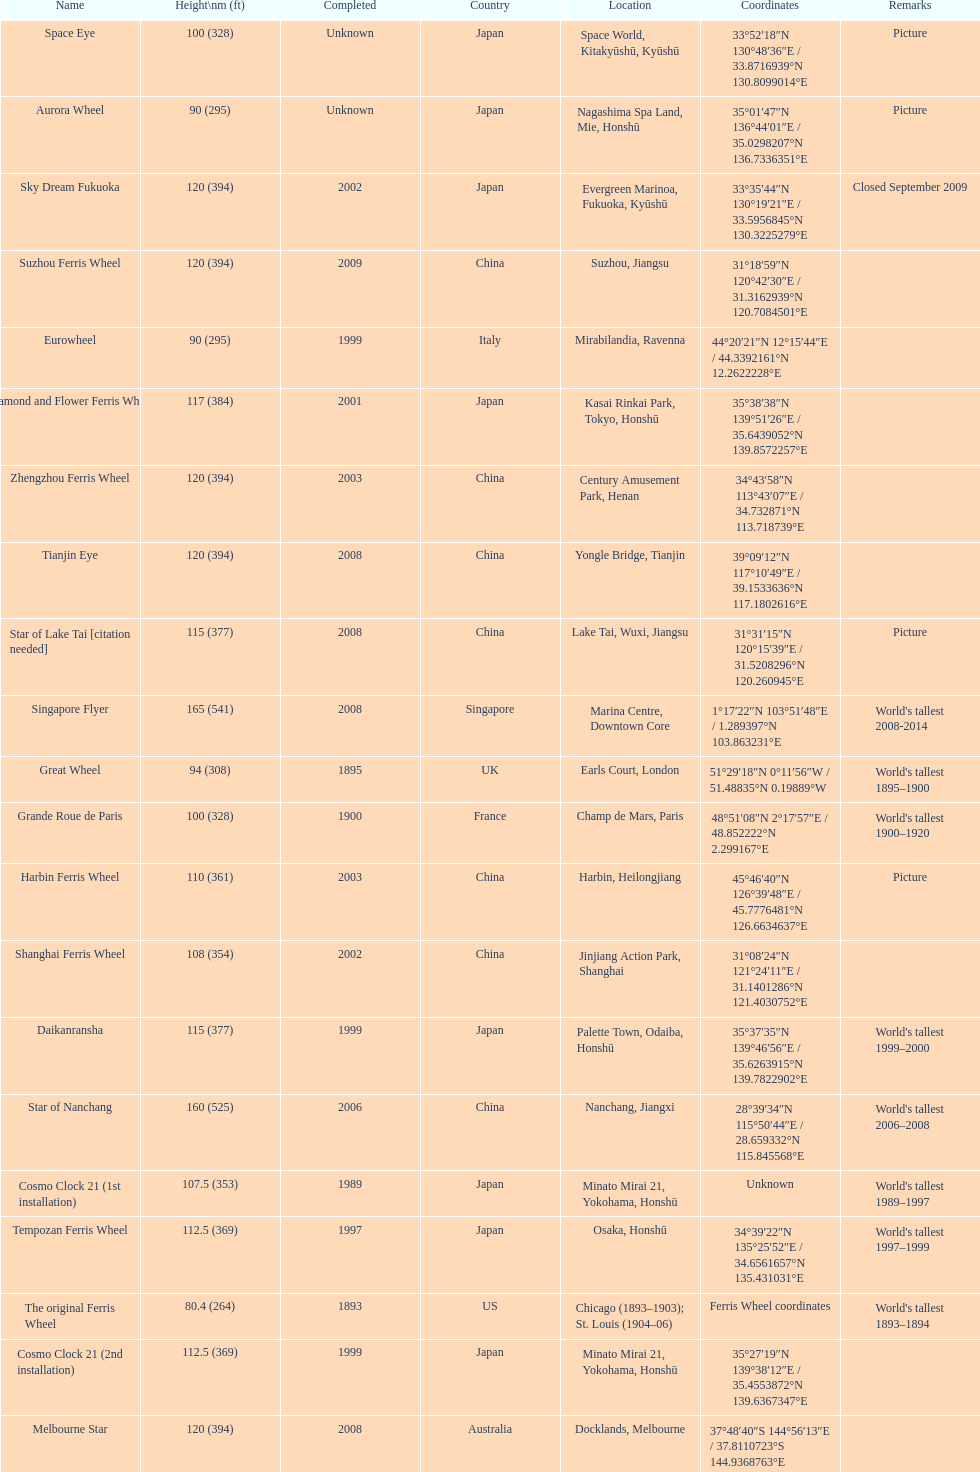Which country had the most roller coasters over 80 feet in height in 2008? China. 